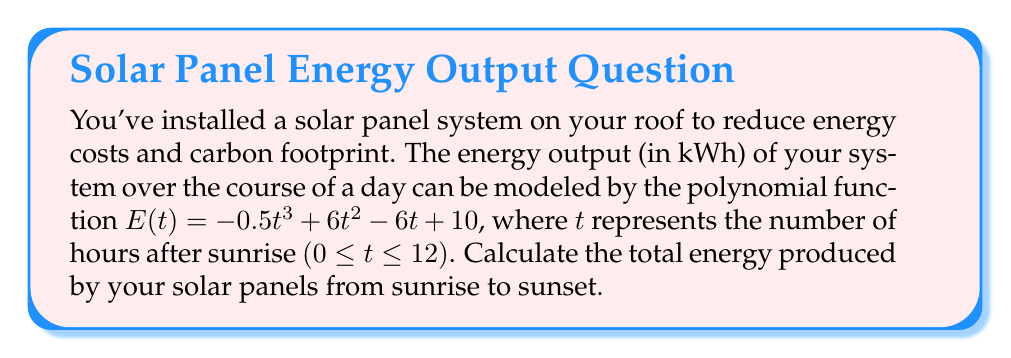Could you help me with this problem? To find the total energy produced by the solar panels over the course of a day, we need to calculate the definite integral of the energy output function from t = 0 (sunrise) to t = 12 (sunset). This will give us the area under the curve of the energy output function, which represents the total energy produced.

The steps to solve this problem are:

1) Set up the definite integral:

   $$\int_0^{12} E(t) dt = \int_0^{12} (-0.5t^3 + 6t^2 - 6t + 10) dt$$

2) Integrate the polynomial function:

   $$\left[-\frac{1}{8}t^4 + 2t^3 - 3t^2 + 10t\right]_0^{12}$$

3) Evaluate the integral at the upper and lower bounds:

   $$\left(-\frac{1}{8}(12)^4 + 2(12)^3 - 3(12)^2 + 10(12)\right) - \left(-\frac{1}{8}(0)^4 + 2(0)^3 - 3(0)^2 + 10(0)\right)$$

4) Simplify:

   $$(-2592 + 3456 - 432 + 120) - (0)$$
   $$= 552$$

Therefore, the total energy produced by your solar panels from sunrise to sunset is 552 kWh.
Answer: 552 kWh 